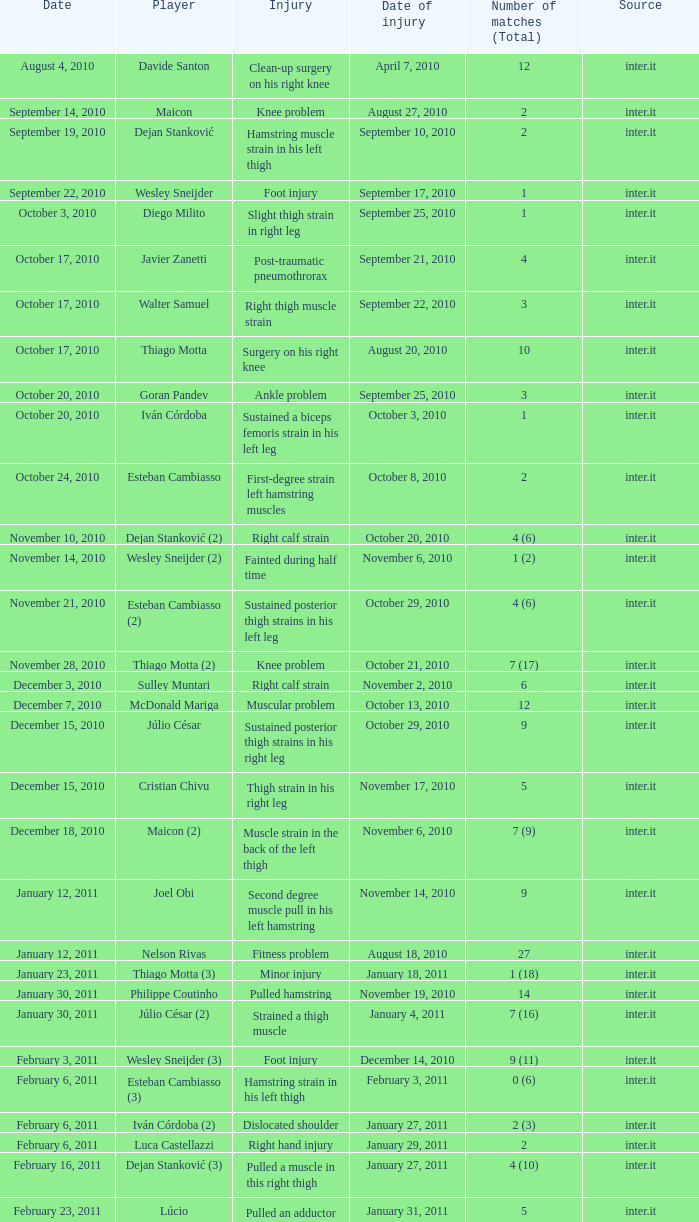What is the date of injury when the injury is sustained posterior thigh strains in his left leg? October 29, 2010. Would you mind parsing the complete table? {'header': ['Date', 'Player', 'Injury', 'Date of injury', 'Number of matches (Total)', 'Source'], 'rows': [['August 4, 2010', 'Davide Santon', 'Clean-up surgery on his right knee', 'April 7, 2010', '12', 'inter.it'], ['September 14, 2010', 'Maicon', 'Knee problem', 'August 27, 2010', '2', 'inter.it'], ['September 19, 2010', 'Dejan Stanković', 'Hamstring muscle strain in his left thigh', 'September 10, 2010', '2', 'inter.it'], ['September 22, 2010', 'Wesley Sneijder', 'Foot injury', 'September 17, 2010', '1', 'inter.it'], ['October 3, 2010', 'Diego Milito', 'Slight thigh strain in right leg', 'September 25, 2010', '1', 'inter.it'], ['October 17, 2010', 'Javier Zanetti', 'Post-traumatic pneumothrorax', 'September 21, 2010', '4', 'inter.it'], ['October 17, 2010', 'Walter Samuel', 'Right thigh muscle strain', 'September 22, 2010', '3', 'inter.it'], ['October 17, 2010', 'Thiago Motta', 'Surgery on his right knee', 'August 20, 2010', '10', 'inter.it'], ['October 20, 2010', 'Goran Pandev', 'Ankle problem', 'September 25, 2010', '3', 'inter.it'], ['October 20, 2010', 'Iván Córdoba', 'Sustained a biceps femoris strain in his left leg', 'October 3, 2010', '1', 'inter.it'], ['October 24, 2010', 'Esteban Cambiasso', 'First-degree strain left hamstring muscles', 'October 8, 2010', '2', 'inter.it'], ['November 10, 2010', 'Dejan Stanković (2)', 'Right calf strain', 'October 20, 2010', '4 (6)', 'inter.it'], ['November 14, 2010', 'Wesley Sneijder (2)', 'Fainted during half time', 'November 6, 2010', '1 (2)', 'inter.it'], ['November 21, 2010', 'Esteban Cambiasso (2)', 'Sustained posterior thigh strains in his left leg', 'October 29, 2010', '4 (6)', 'inter.it'], ['November 28, 2010', 'Thiago Motta (2)', 'Knee problem', 'October 21, 2010', '7 (17)', 'inter.it'], ['December 3, 2010', 'Sulley Muntari', 'Right calf strain', 'November 2, 2010', '6', 'inter.it'], ['December 7, 2010', 'McDonald Mariga', 'Muscular problem', 'October 13, 2010', '12', 'inter.it'], ['December 15, 2010', 'Júlio César', 'Sustained posterior thigh strains in his right leg', 'October 29, 2010', '9', 'inter.it'], ['December 15, 2010', 'Cristian Chivu', 'Thigh strain in his right leg', 'November 17, 2010', '5', 'inter.it'], ['December 18, 2010', 'Maicon (2)', 'Muscle strain in the back of the left thigh', 'November 6, 2010', '7 (9)', 'inter.it'], ['January 12, 2011', 'Joel Obi', 'Second degree muscle pull in his left hamstring', 'November 14, 2010', '9', 'inter.it'], ['January 12, 2011', 'Nelson Rivas', 'Fitness problem', 'August 18, 2010', '27', 'inter.it'], ['January 23, 2011', 'Thiago Motta (3)', 'Minor injury', 'January 18, 2011', '1 (18)', 'inter.it'], ['January 30, 2011', 'Philippe Coutinho', 'Pulled hamstring', 'November 19, 2010', '14', 'inter.it'], ['January 30, 2011', 'Júlio César (2)', 'Strained a thigh muscle', 'January 4, 2011', '7 (16)', 'inter.it'], ['February 3, 2011', 'Wesley Sneijder (3)', 'Foot injury', 'December 14, 2010', '9 (11)', 'inter.it'], ['February 6, 2011', 'Esteban Cambiasso (3)', 'Hamstring strain in his left thigh', 'February 3, 2011', '0 (6)', 'inter.it'], ['February 6, 2011', 'Iván Córdoba (2)', 'Dislocated shoulder', 'January 27, 2011', '2 (3)', 'inter.it'], ['February 6, 2011', 'Luca Castellazzi', 'Right hand injury', 'January 29, 2011', '2', 'inter.it'], ['February 16, 2011', 'Dejan Stanković (3)', 'Pulled a muscle in this right thigh', 'January 27, 2011', '4 (10)', 'inter.it'], ['February 23, 2011', 'Lúcio', 'Pulled an adductor muscle in his right thigh', 'January 31, 2011', '5', 'inter.it']]} 